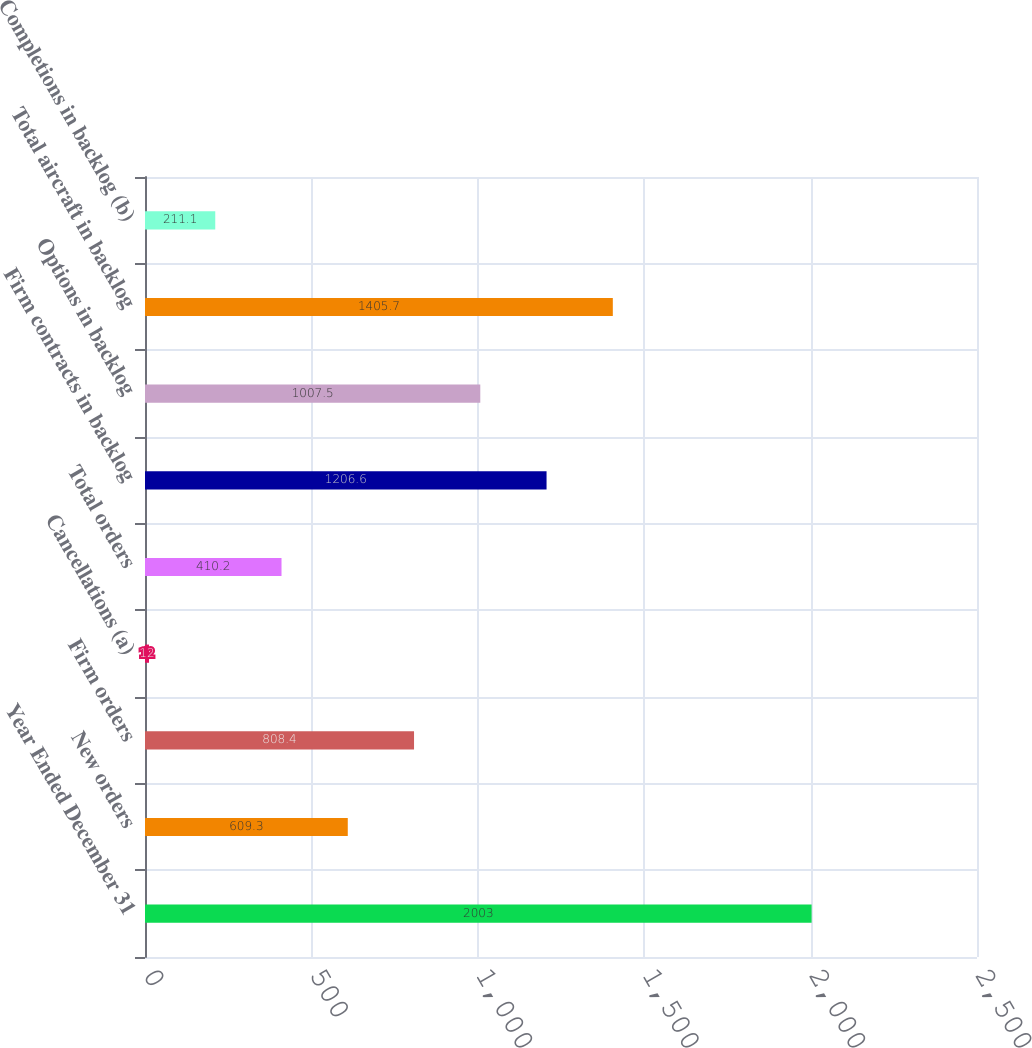Convert chart to OTSL. <chart><loc_0><loc_0><loc_500><loc_500><bar_chart><fcel>Year Ended December 31<fcel>New orders<fcel>Firm orders<fcel>Cancellations (a)<fcel>Total orders<fcel>Firm contracts in backlog<fcel>Options in backlog<fcel>Total aircraft in backlog<fcel>Completions in backlog (b)<nl><fcel>2003<fcel>609.3<fcel>808.4<fcel>12<fcel>410.2<fcel>1206.6<fcel>1007.5<fcel>1405.7<fcel>211.1<nl></chart> 